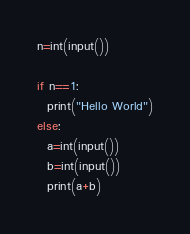Convert code to text. <code><loc_0><loc_0><loc_500><loc_500><_Python_>n=int(input())

if n==1:
  print("Hello World")
else:
  a=int(input())
  b=int(input())
  print(a+b)</code> 